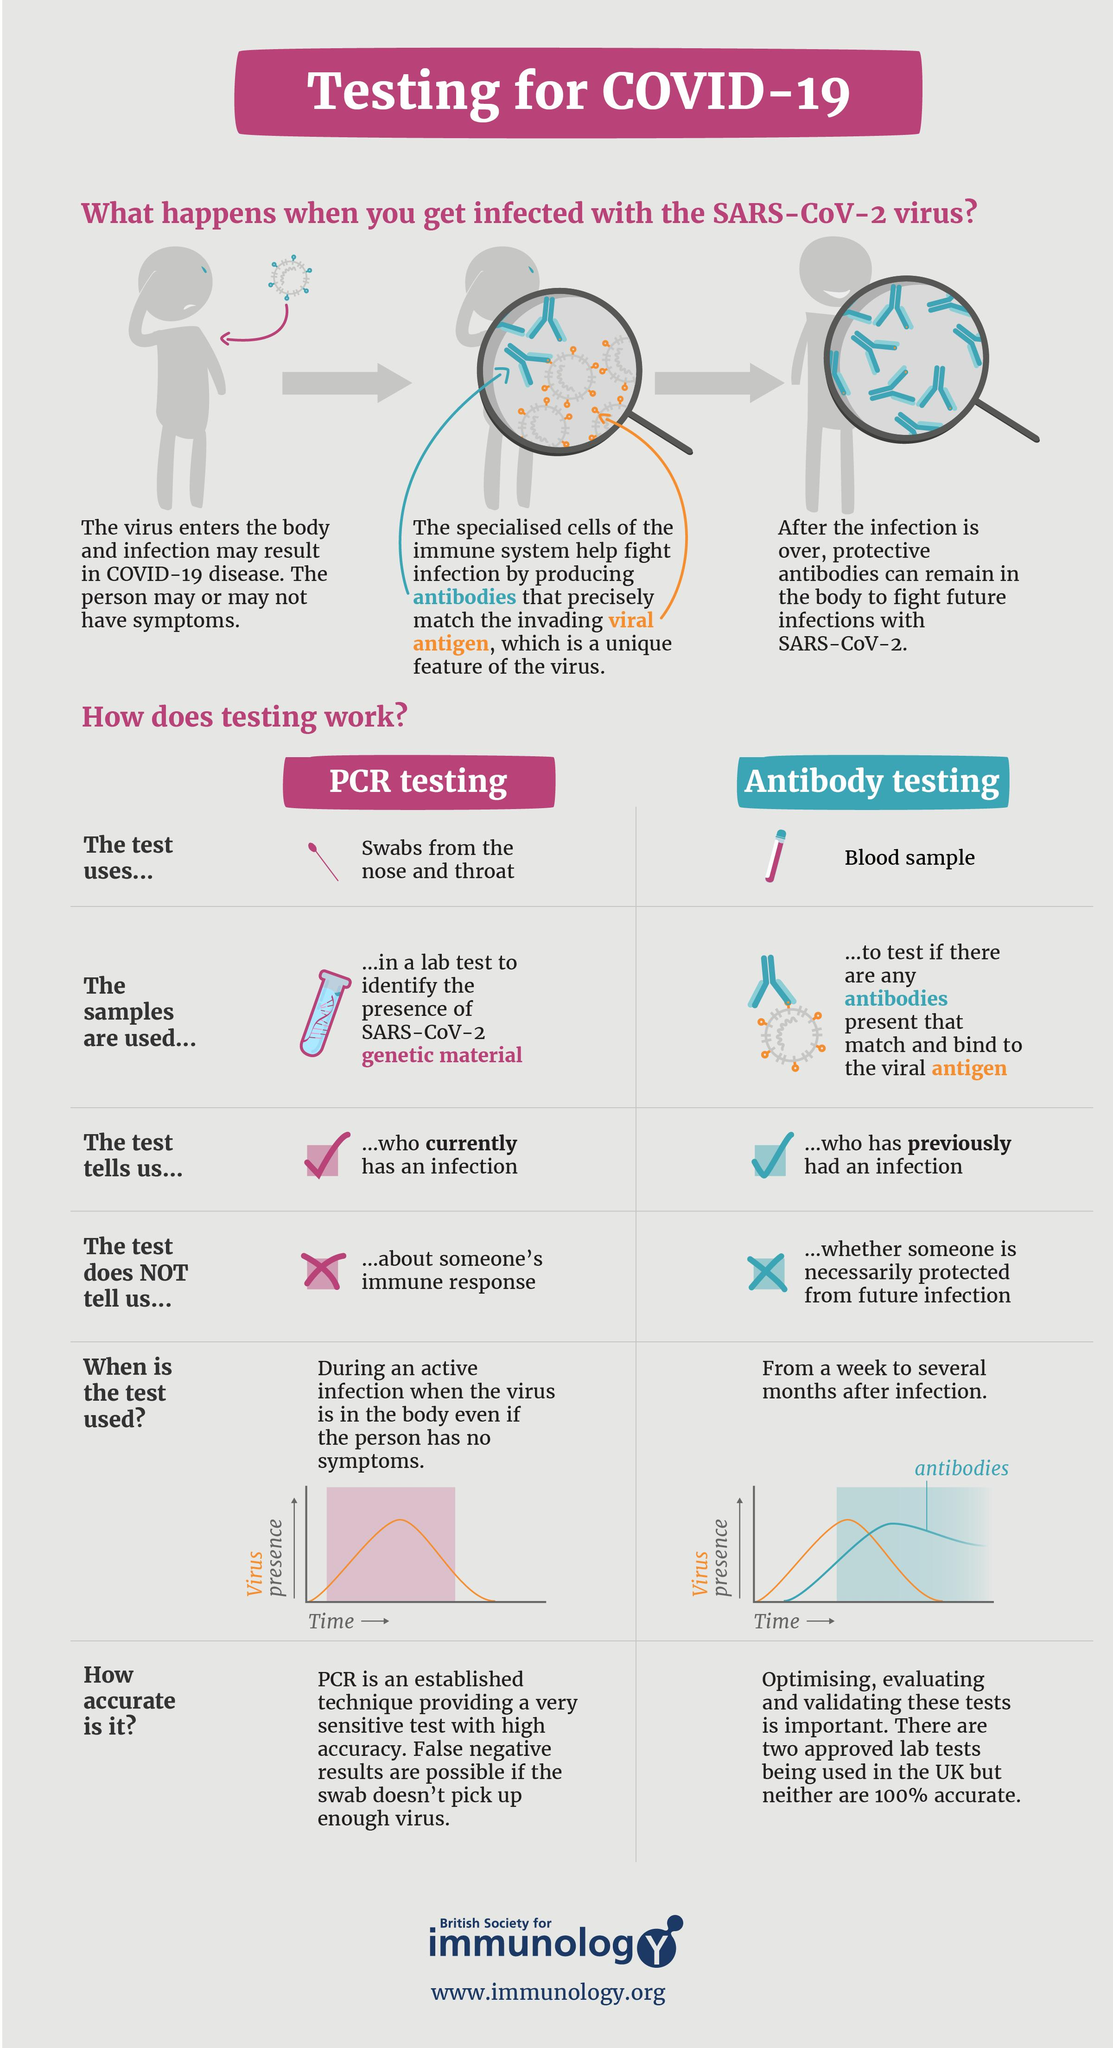Mention a couple of crucial points in this snapshot. The test that detects the presence of antibodies that bind to the viral antigen is called antibody testing. The PCR test uses swabs from the nose and throat to test for COVID-19. PCR testing is the test used to determine if a person currently has an infection. Antibody test results do not necessarily indicate whether someone is immune to future infection. The PCR test does not provide information about a person's immune response. 